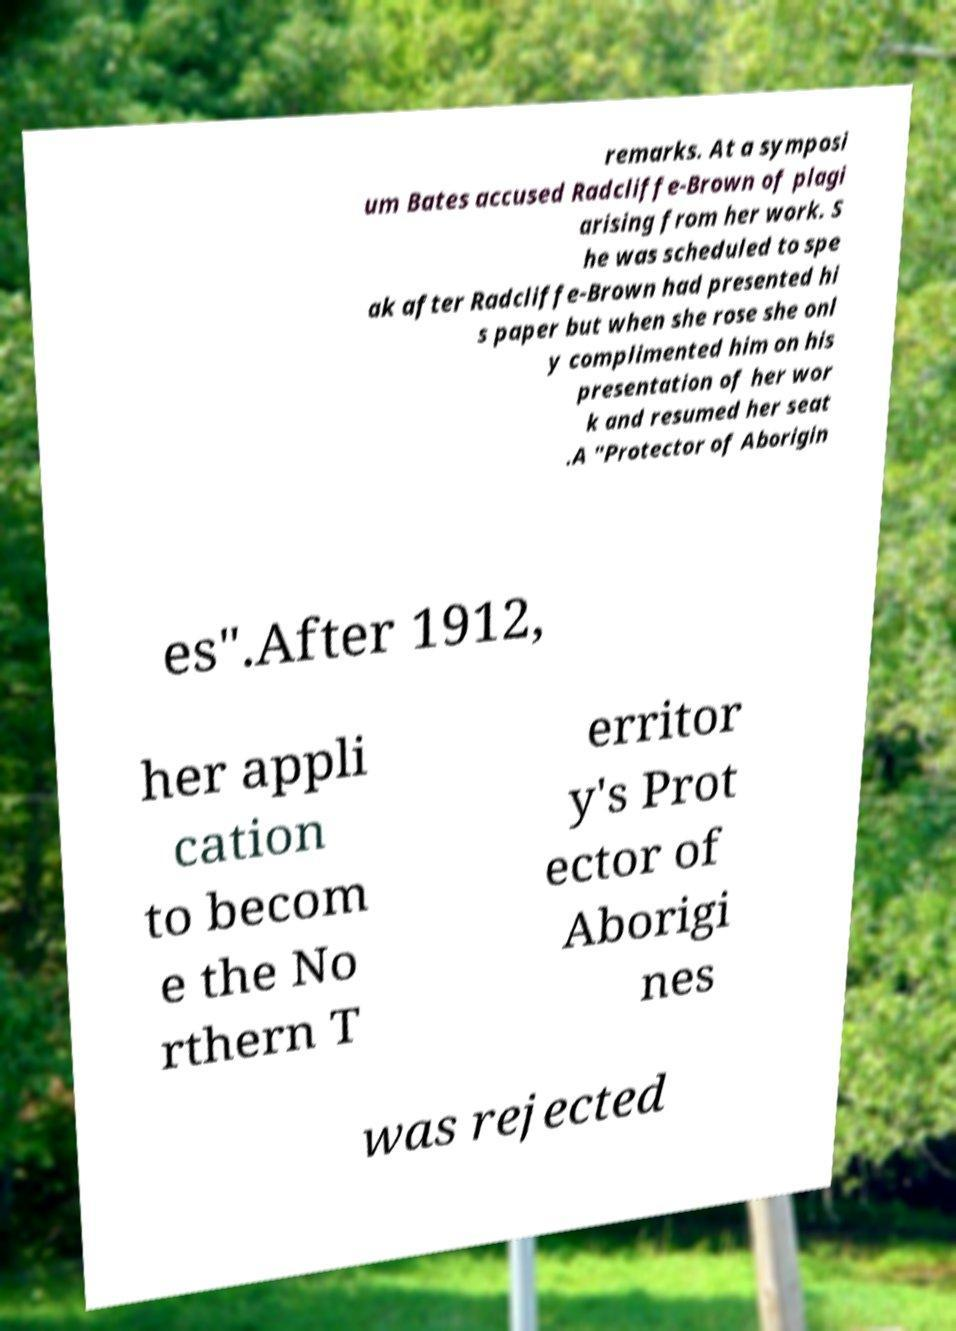Could you extract and type out the text from this image? remarks. At a symposi um Bates accused Radcliffe-Brown of plagi arising from her work. S he was scheduled to spe ak after Radcliffe-Brown had presented hi s paper but when she rose she onl y complimented him on his presentation of her wor k and resumed her seat .A "Protector of Aborigin es".After 1912, her appli cation to becom e the No rthern T erritor y's Prot ector of Aborigi nes was rejected 